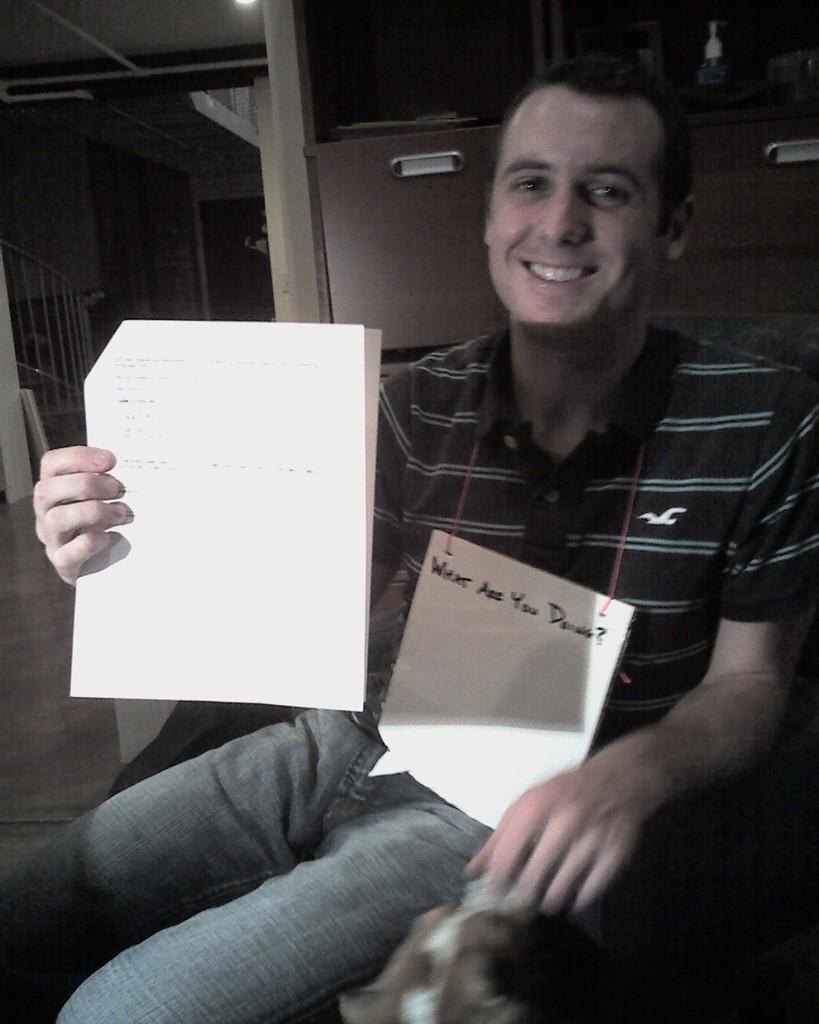Who is present in the image? There is a person in the image. What is the person doing? The person is smiling. What is the person holding in his hand? The person is holding papers in his hand. What can be seen behind the person? There are two cabinets behind the person. What architectural feature is visible in the background of the image? There are stairs on the left side in the background of the image. What type of clam is the person holding in the image? There is no clam present in the image; the person is holding papers in his hand. 